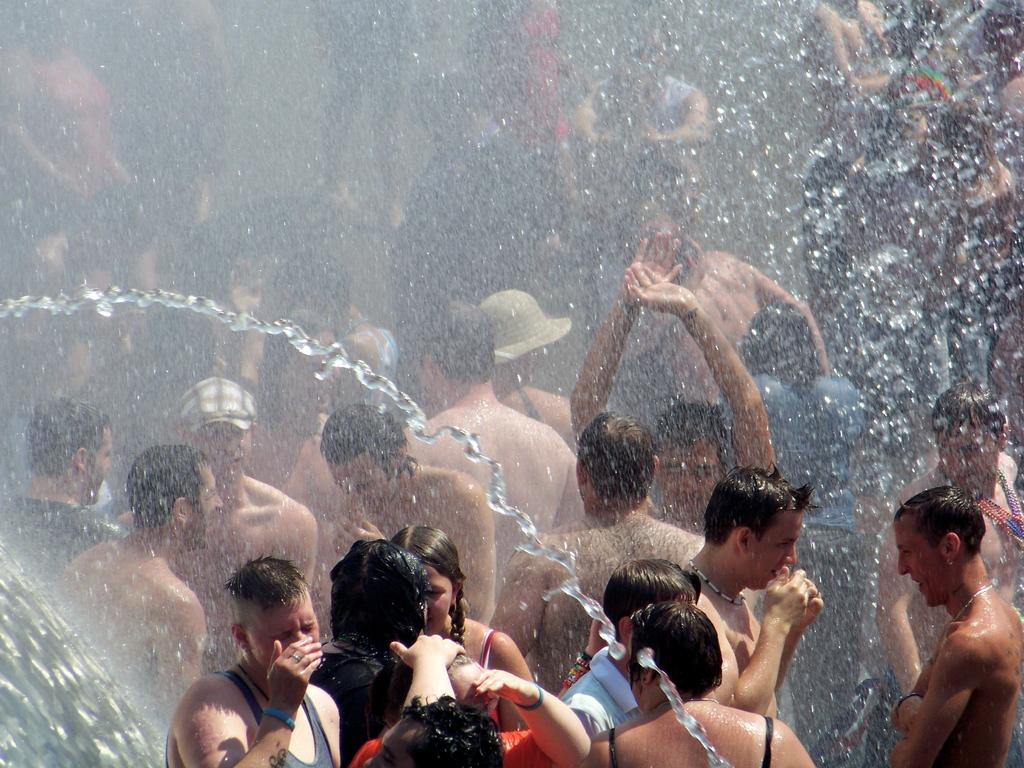How many people are in the image? There are people in the image. What are the people doing in the image? The people are playing with water. Can you describe the activity they are engaged in? The activity resembles a rain dance. What type of tub can be seen in the image? There is no tub present in the image. What kind of soup is being prepared in the image? There is no soup preparation in the image. Can you tell me how many cacti are visible in the image? There is no cactus present in the image. 